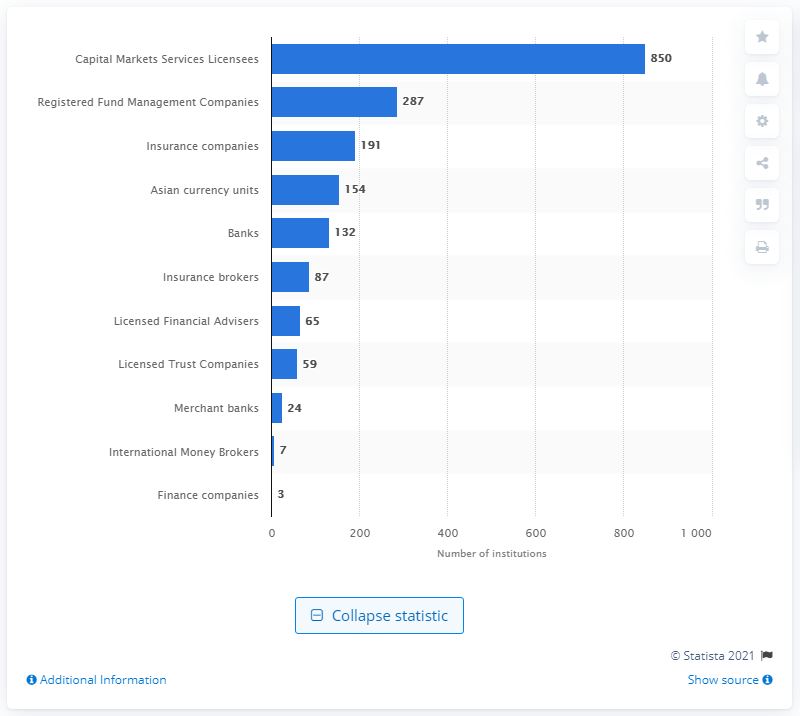Highlight a few significant elements in this photo. There were 191 insurance companies operating in Singapore in 2020. In 2020, there were 850 capital markets licensees in Singapore. 